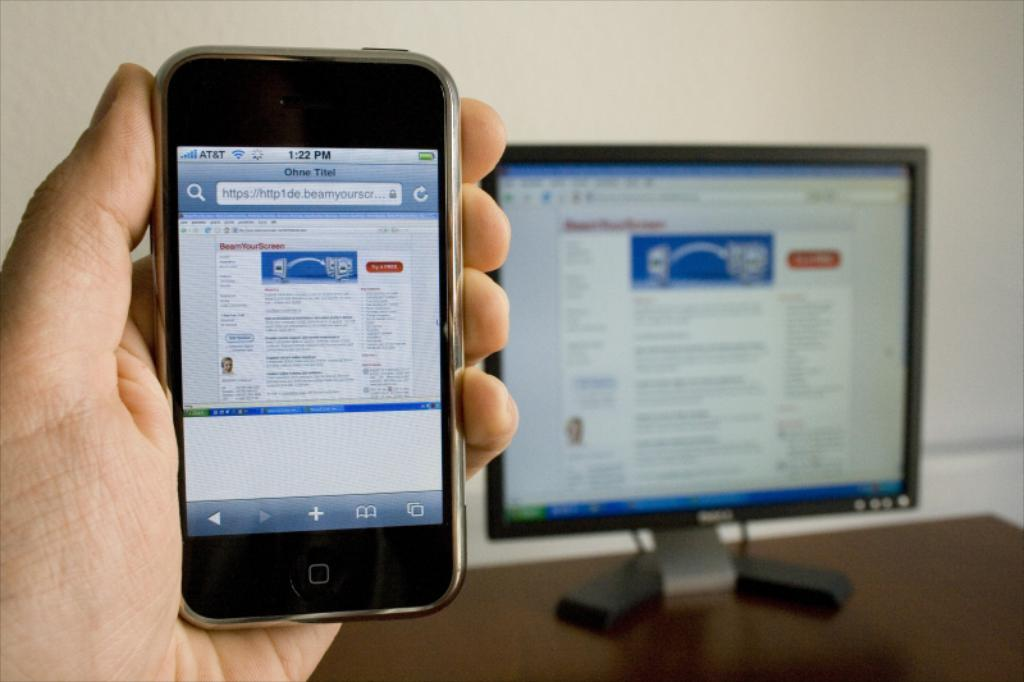What is the main subject in the foreground of the image? There is a person in the foreground of the image. What is the person holding in the image? The person is holding a mobile. What can be seen on a table in the background of the image? There is a computer on a table in the background of the image. What type of structure is visible in the background of the image? There is a wall visible in the background of the image. What type of prose is being written on the side of the wall in the image? There is no writing or prose visible on the wall in the image. 